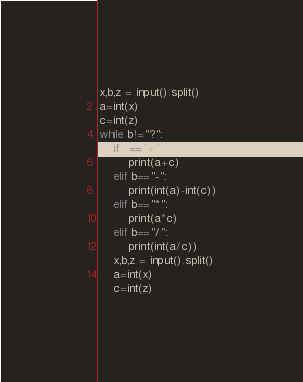Convert code to text. <code><loc_0><loc_0><loc_500><loc_500><_Python_>x,b,z = input().split()
a=int(x)
c=int(z)
while b!="?":
    if b=="+":
        print(a+c)
    elif b=="-":
        print(int(a)-int(c))
    elif b=="*":
        print(a*c)
    elif b=="/":
        print(int(a/c))
    x,b,z = input().split()
    a=int(x)
    c=int(z)</code> 